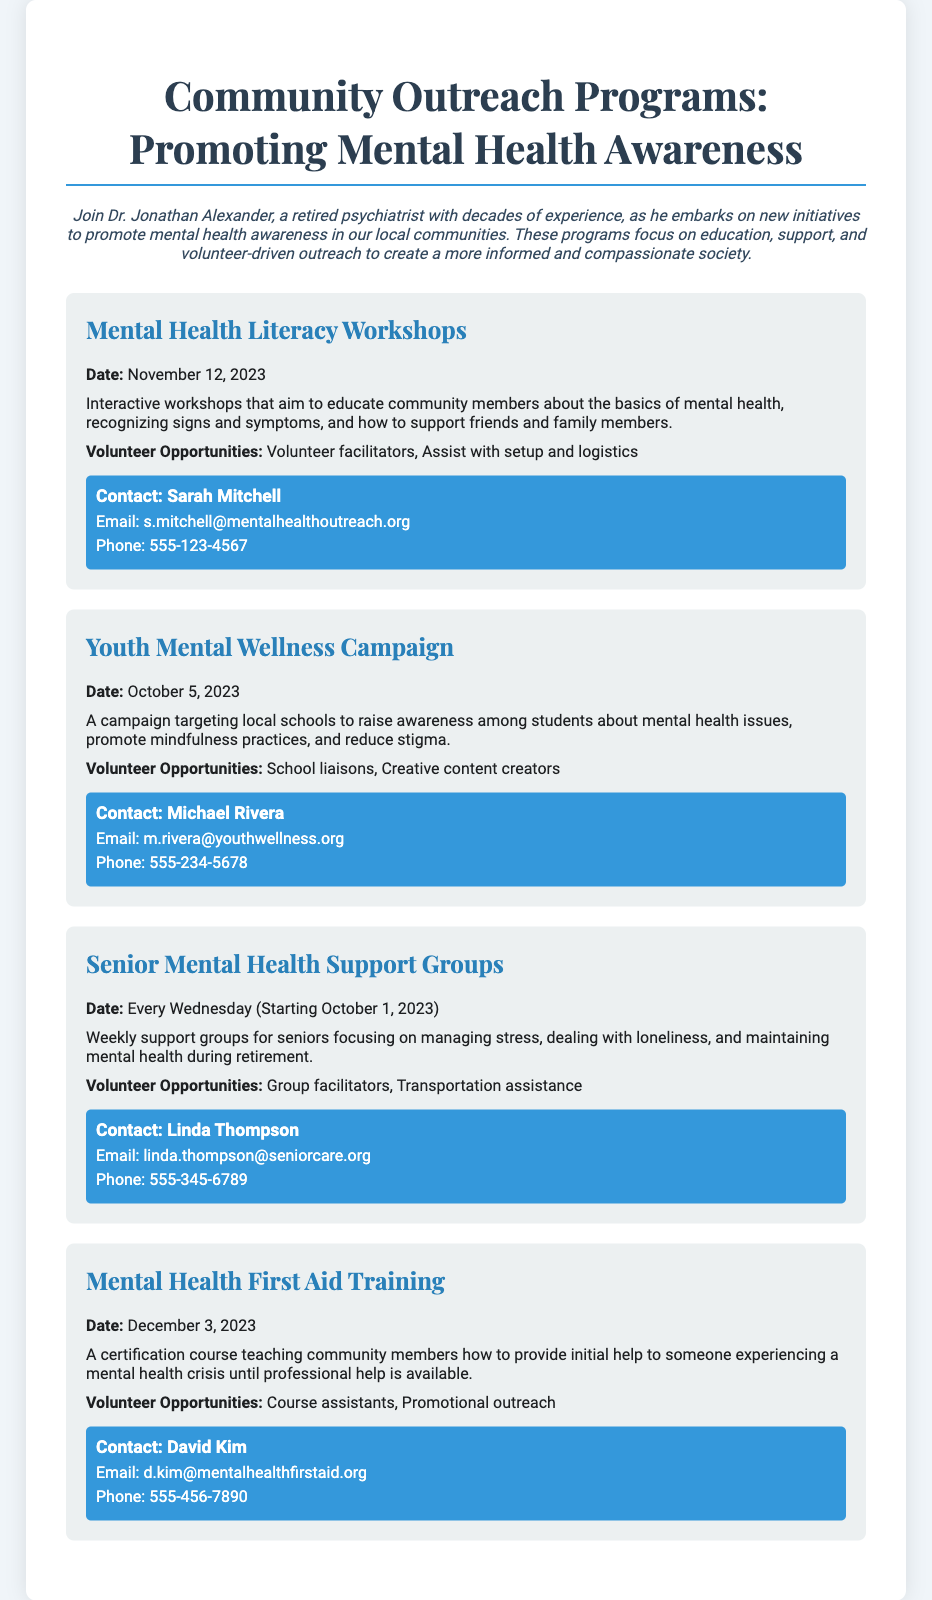What is the title of the first program listed? The title of the first program is prominently displayed at the start of its section.
Answer: Mental Health Literacy Workshops What is the date of the Youth Mental Wellness Campaign? The date is clearly stated in the program details.
Answer: October 5, 2023 Who should be contacted for the Senior Mental Health Support Groups? The contact information is included in the program details.
Answer: Linda Thompson What type of training is offered on December 3, 2023? The type of training is specified in the program's description.
Answer: Mental Health First Aid Training On what day do the Senior Mental Health Support Groups occur? The day of the week is mentioned in the program schedule.
Answer: Every Wednesday What are the volunteer opportunities for the Mental Health Literacy Workshops? The opportunities are listed under the respective program's details.
Answer: Volunteer facilitators, Assist with setup and logistics What is the primary focus of the Youth Mental Wellness Campaign? The focus is stated in the program description.
Answer: Raise awareness among students about mental health issues How often do the Senior Mental Health Support Groups meet? The frequency is noted in the program schedule.
Answer: Weekly Who can assist with the Mental Health First Aid Training promotions? The program details include volunteer roles available for assistance.
Answer: Course assistants, Promotional outreach 